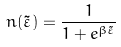<formula> <loc_0><loc_0><loc_500><loc_500>n ( \tilde { \varepsilon } ) = \frac { 1 } { 1 + e ^ { \beta \tilde { \varepsilon } } }</formula> 